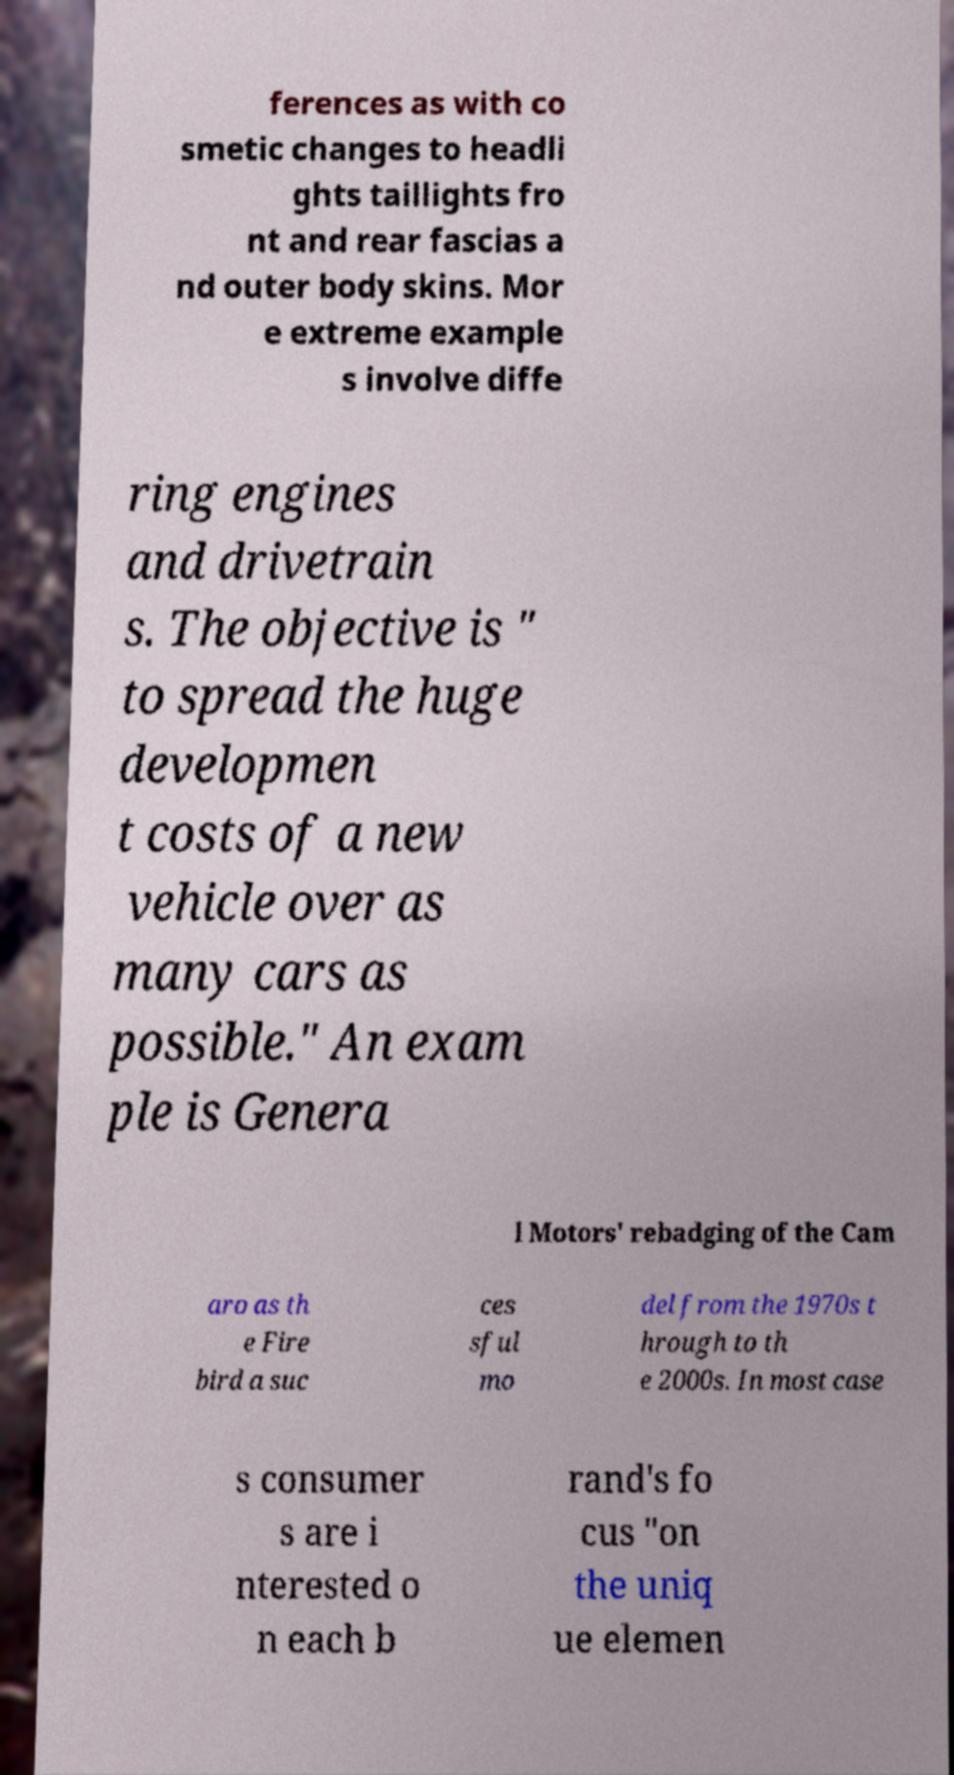Can you accurately transcribe the text from the provided image for me? ferences as with co smetic changes to headli ghts taillights fro nt and rear fascias a nd outer body skins. Mor e extreme example s involve diffe ring engines and drivetrain s. The objective is " to spread the huge developmen t costs of a new vehicle over as many cars as possible." An exam ple is Genera l Motors' rebadging of the Cam aro as th e Fire bird a suc ces sful mo del from the 1970s t hrough to th e 2000s. In most case s consumer s are i nterested o n each b rand's fo cus "on the uniq ue elemen 